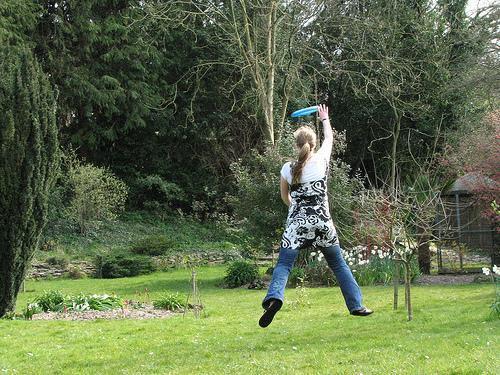How many girls are there?
Give a very brief answer. 1. 